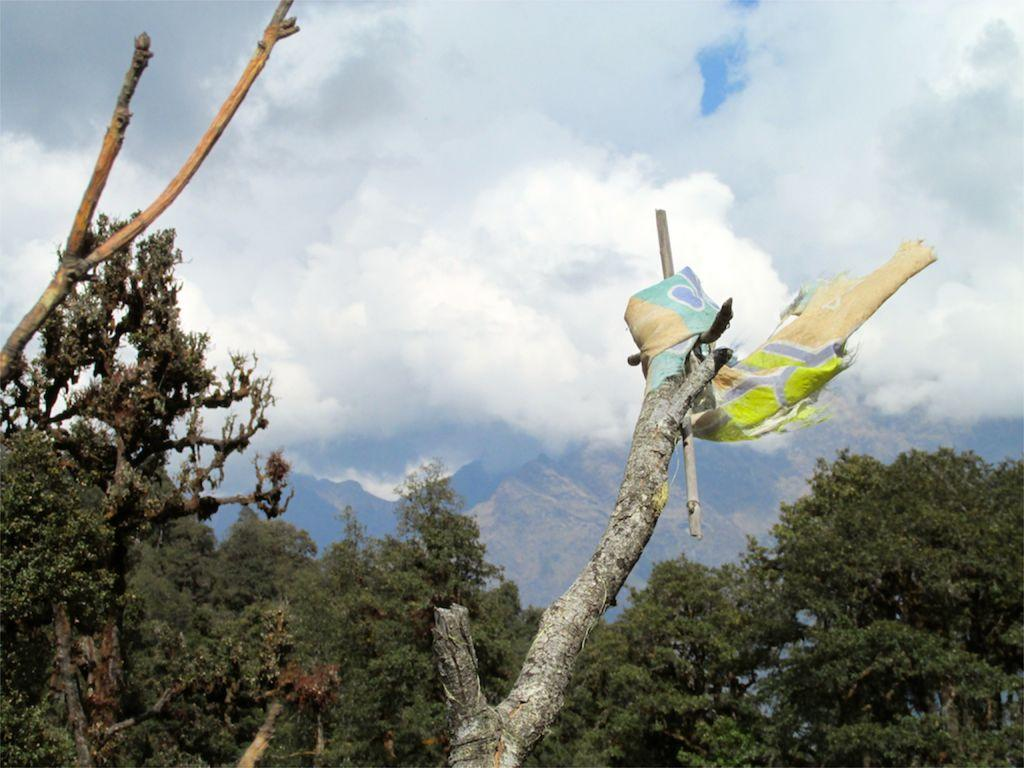What type of vegetation can be seen in the image? There are trees in the image. Is there anything unusual hanging on one of the trees? Yes, there is a cloth hanging on one of the trees. What can be seen in the distance behind the trees? There are mountains in the background of the image. What part of the natural environment is visible in the image? The sky is visible in the background of the image. What type of jam is being spread on the wilderness in the image? There is no jam or wilderness present in the image; it features trees, a cloth, mountains, and the sky. 